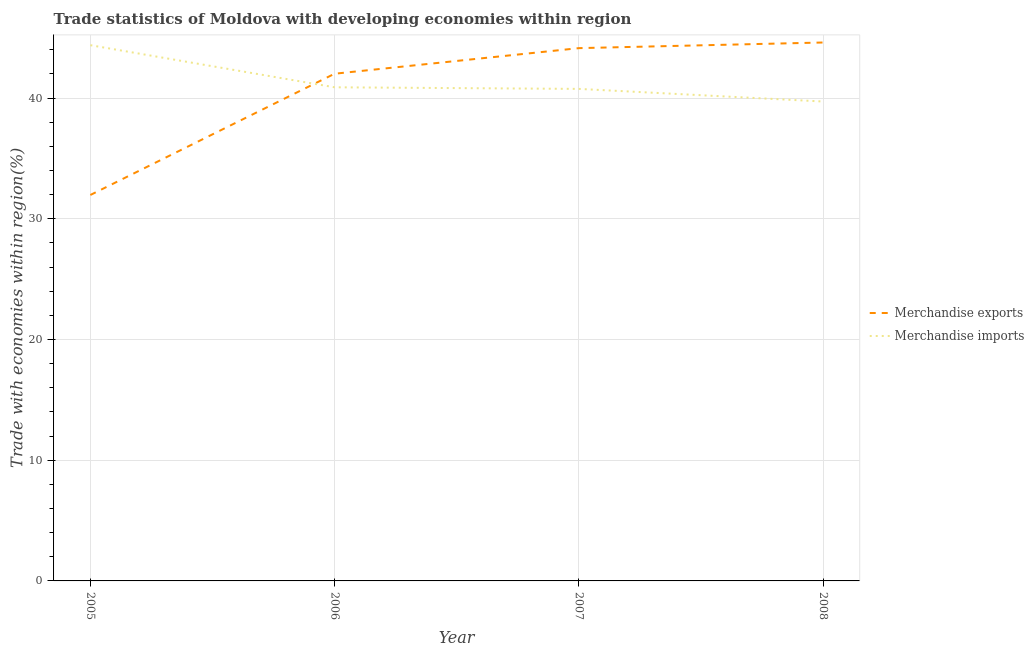Does the line corresponding to merchandise imports intersect with the line corresponding to merchandise exports?
Your answer should be compact. Yes. Is the number of lines equal to the number of legend labels?
Your answer should be compact. Yes. What is the merchandise imports in 2008?
Make the answer very short. 39.72. Across all years, what is the maximum merchandise imports?
Give a very brief answer. 44.39. Across all years, what is the minimum merchandise imports?
Offer a very short reply. 39.72. What is the total merchandise exports in the graph?
Make the answer very short. 162.75. What is the difference between the merchandise exports in 2005 and that in 2007?
Give a very brief answer. -12.17. What is the difference between the merchandise imports in 2006 and the merchandise exports in 2005?
Keep it short and to the point. 8.92. What is the average merchandise imports per year?
Offer a very short reply. 41.44. In the year 2005, what is the difference between the merchandise imports and merchandise exports?
Keep it short and to the point. 12.41. In how many years, is the merchandise imports greater than 22 %?
Provide a short and direct response. 4. What is the ratio of the merchandise exports in 2005 to that in 2007?
Your answer should be very brief. 0.72. What is the difference between the highest and the second highest merchandise imports?
Make the answer very short. 3.49. What is the difference between the highest and the lowest merchandise imports?
Ensure brevity in your answer.  4.67. Is the sum of the merchandise imports in 2005 and 2007 greater than the maximum merchandise exports across all years?
Provide a succinct answer. Yes. Does the merchandise imports monotonically increase over the years?
Offer a very short reply. No. Is the merchandise exports strictly greater than the merchandise imports over the years?
Your answer should be very brief. No. How many lines are there?
Give a very brief answer. 2. Does the graph contain grids?
Ensure brevity in your answer.  Yes. Where does the legend appear in the graph?
Your answer should be compact. Center right. How many legend labels are there?
Provide a succinct answer. 2. How are the legend labels stacked?
Make the answer very short. Vertical. What is the title of the graph?
Ensure brevity in your answer.  Trade statistics of Moldova with developing economies within region. Does "Grants" appear as one of the legend labels in the graph?
Keep it short and to the point. No. What is the label or title of the Y-axis?
Provide a short and direct response. Trade with economies within region(%). What is the Trade with economies within region(%) in Merchandise exports in 2005?
Offer a very short reply. 31.97. What is the Trade with economies within region(%) in Merchandise imports in 2005?
Your response must be concise. 44.39. What is the Trade with economies within region(%) in Merchandise exports in 2006?
Keep it short and to the point. 42.02. What is the Trade with economies within region(%) of Merchandise imports in 2006?
Your answer should be compact. 40.9. What is the Trade with economies within region(%) in Merchandise exports in 2007?
Ensure brevity in your answer.  44.14. What is the Trade with economies within region(%) of Merchandise imports in 2007?
Your answer should be compact. 40.76. What is the Trade with economies within region(%) in Merchandise exports in 2008?
Offer a very short reply. 44.61. What is the Trade with economies within region(%) in Merchandise imports in 2008?
Provide a short and direct response. 39.72. Across all years, what is the maximum Trade with economies within region(%) of Merchandise exports?
Keep it short and to the point. 44.61. Across all years, what is the maximum Trade with economies within region(%) of Merchandise imports?
Offer a very short reply. 44.39. Across all years, what is the minimum Trade with economies within region(%) of Merchandise exports?
Offer a terse response. 31.97. Across all years, what is the minimum Trade with economies within region(%) in Merchandise imports?
Provide a succinct answer. 39.72. What is the total Trade with economies within region(%) of Merchandise exports in the graph?
Provide a succinct answer. 162.75. What is the total Trade with economies within region(%) of Merchandise imports in the graph?
Give a very brief answer. 165.77. What is the difference between the Trade with economies within region(%) of Merchandise exports in 2005 and that in 2006?
Give a very brief answer. -10.05. What is the difference between the Trade with economies within region(%) in Merchandise imports in 2005 and that in 2006?
Ensure brevity in your answer.  3.49. What is the difference between the Trade with economies within region(%) of Merchandise exports in 2005 and that in 2007?
Provide a succinct answer. -12.17. What is the difference between the Trade with economies within region(%) in Merchandise imports in 2005 and that in 2007?
Offer a terse response. 3.62. What is the difference between the Trade with economies within region(%) of Merchandise exports in 2005 and that in 2008?
Make the answer very short. -12.63. What is the difference between the Trade with economies within region(%) in Merchandise imports in 2005 and that in 2008?
Make the answer very short. 4.67. What is the difference between the Trade with economies within region(%) of Merchandise exports in 2006 and that in 2007?
Keep it short and to the point. -2.12. What is the difference between the Trade with economies within region(%) in Merchandise imports in 2006 and that in 2007?
Keep it short and to the point. 0.13. What is the difference between the Trade with economies within region(%) of Merchandise exports in 2006 and that in 2008?
Provide a short and direct response. -2.59. What is the difference between the Trade with economies within region(%) of Merchandise imports in 2006 and that in 2008?
Ensure brevity in your answer.  1.18. What is the difference between the Trade with economies within region(%) of Merchandise exports in 2007 and that in 2008?
Ensure brevity in your answer.  -0.47. What is the difference between the Trade with economies within region(%) of Merchandise imports in 2007 and that in 2008?
Your answer should be very brief. 1.05. What is the difference between the Trade with economies within region(%) of Merchandise exports in 2005 and the Trade with economies within region(%) of Merchandise imports in 2006?
Make the answer very short. -8.92. What is the difference between the Trade with economies within region(%) in Merchandise exports in 2005 and the Trade with economies within region(%) in Merchandise imports in 2007?
Your answer should be compact. -8.79. What is the difference between the Trade with economies within region(%) of Merchandise exports in 2005 and the Trade with economies within region(%) of Merchandise imports in 2008?
Ensure brevity in your answer.  -7.74. What is the difference between the Trade with economies within region(%) of Merchandise exports in 2006 and the Trade with economies within region(%) of Merchandise imports in 2007?
Keep it short and to the point. 1.26. What is the difference between the Trade with economies within region(%) of Merchandise exports in 2006 and the Trade with economies within region(%) of Merchandise imports in 2008?
Ensure brevity in your answer.  2.3. What is the difference between the Trade with economies within region(%) in Merchandise exports in 2007 and the Trade with economies within region(%) in Merchandise imports in 2008?
Make the answer very short. 4.42. What is the average Trade with economies within region(%) in Merchandise exports per year?
Your response must be concise. 40.69. What is the average Trade with economies within region(%) of Merchandise imports per year?
Your answer should be very brief. 41.44. In the year 2005, what is the difference between the Trade with economies within region(%) of Merchandise exports and Trade with economies within region(%) of Merchandise imports?
Provide a short and direct response. -12.41. In the year 2006, what is the difference between the Trade with economies within region(%) in Merchandise exports and Trade with economies within region(%) in Merchandise imports?
Your response must be concise. 1.12. In the year 2007, what is the difference between the Trade with economies within region(%) of Merchandise exports and Trade with economies within region(%) of Merchandise imports?
Offer a terse response. 3.38. In the year 2008, what is the difference between the Trade with economies within region(%) in Merchandise exports and Trade with economies within region(%) in Merchandise imports?
Offer a terse response. 4.89. What is the ratio of the Trade with economies within region(%) in Merchandise exports in 2005 to that in 2006?
Your response must be concise. 0.76. What is the ratio of the Trade with economies within region(%) in Merchandise imports in 2005 to that in 2006?
Make the answer very short. 1.09. What is the ratio of the Trade with economies within region(%) in Merchandise exports in 2005 to that in 2007?
Your answer should be compact. 0.72. What is the ratio of the Trade with economies within region(%) of Merchandise imports in 2005 to that in 2007?
Give a very brief answer. 1.09. What is the ratio of the Trade with economies within region(%) of Merchandise exports in 2005 to that in 2008?
Your answer should be very brief. 0.72. What is the ratio of the Trade with economies within region(%) of Merchandise imports in 2005 to that in 2008?
Keep it short and to the point. 1.12. What is the ratio of the Trade with economies within region(%) in Merchandise exports in 2006 to that in 2007?
Give a very brief answer. 0.95. What is the ratio of the Trade with economies within region(%) of Merchandise exports in 2006 to that in 2008?
Provide a short and direct response. 0.94. What is the ratio of the Trade with economies within region(%) in Merchandise imports in 2006 to that in 2008?
Give a very brief answer. 1.03. What is the ratio of the Trade with economies within region(%) in Merchandise imports in 2007 to that in 2008?
Make the answer very short. 1.03. What is the difference between the highest and the second highest Trade with economies within region(%) in Merchandise exports?
Give a very brief answer. 0.47. What is the difference between the highest and the second highest Trade with economies within region(%) in Merchandise imports?
Make the answer very short. 3.49. What is the difference between the highest and the lowest Trade with economies within region(%) in Merchandise exports?
Make the answer very short. 12.63. What is the difference between the highest and the lowest Trade with economies within region(%) in Merchandise imports?
Your response must be concise. 4.67. 